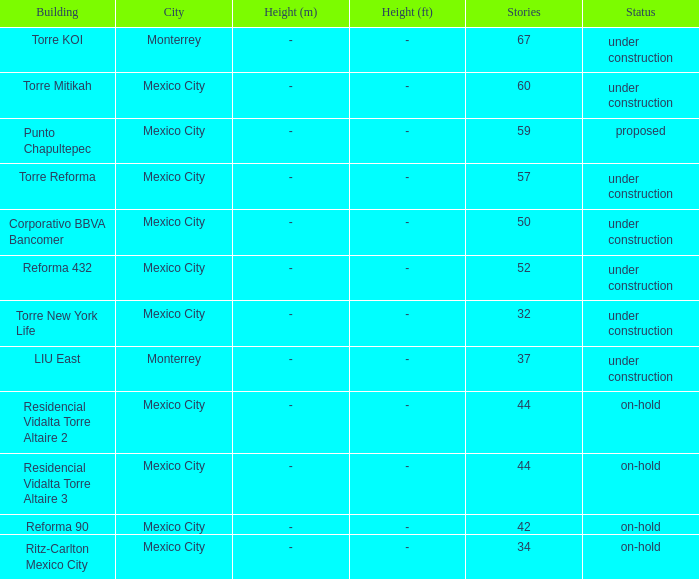What is the status of the torre reforma building that is over 44 stories in mexico city? Under construction. 